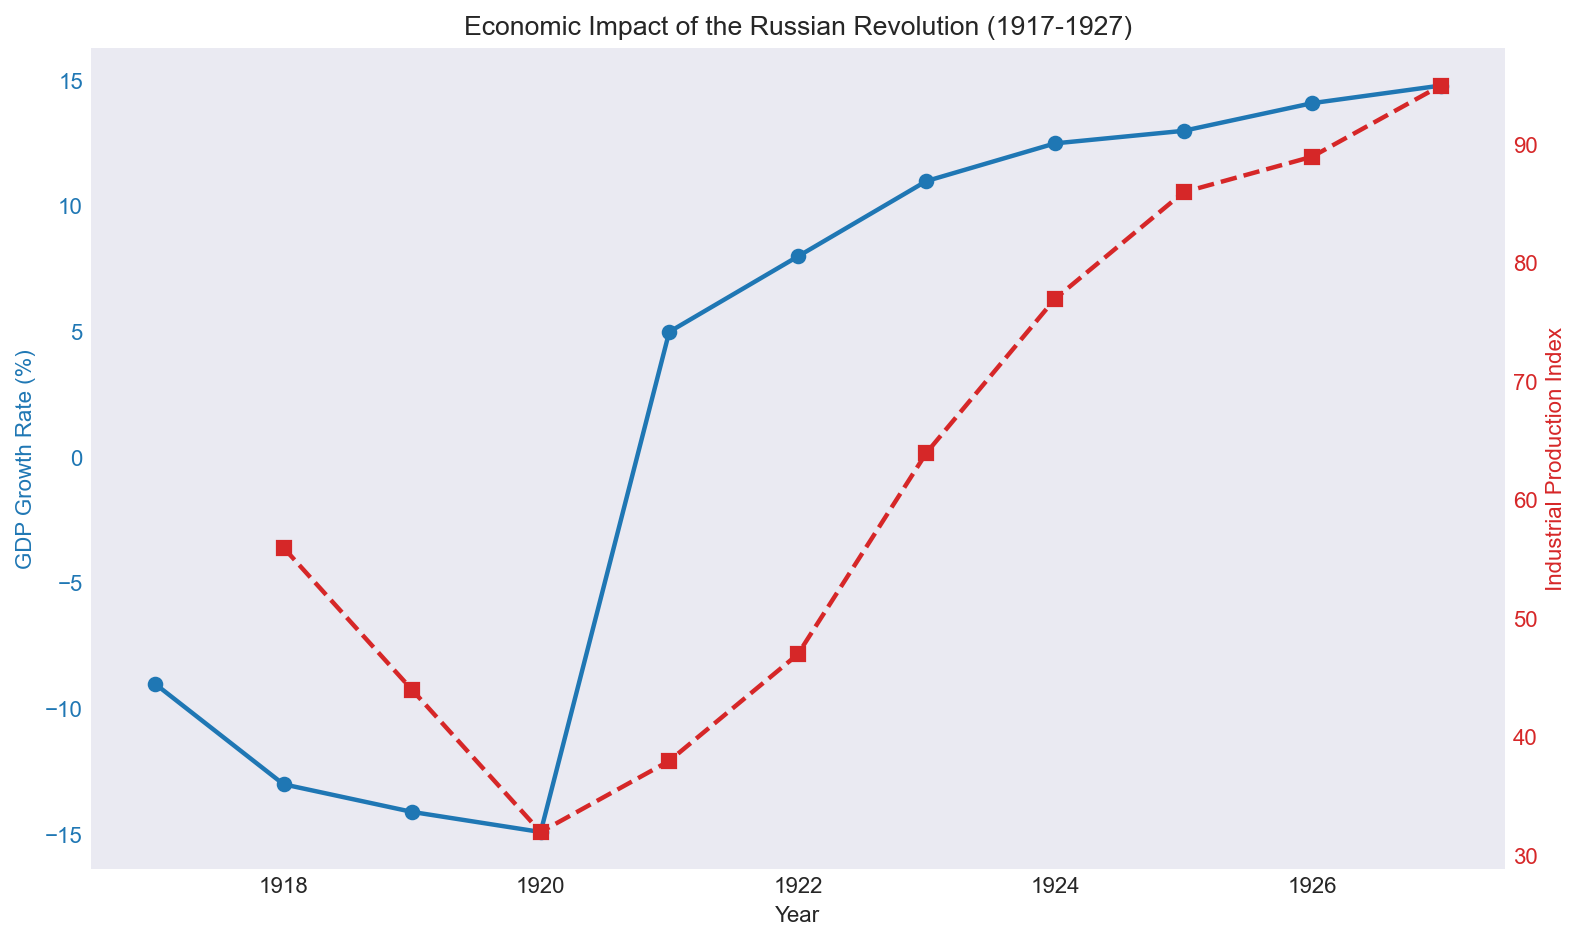What was the GDP growth rate in 1921? According to the chart, the GDP growth rate in 1921 was notable. By directly referencing the plotted data point for that year on the blue line, we observe that the GDP growth rate was 5.0%.
Answer: 5.0% Which year saw the lowest industrial production index? By examining the red dashed line, it is noticeable that the Industrial Production Index was at its lowest point in 1920, with a value of 32.
Answer: 1920 How did the industrial production change between 1922 and 1923? To determine the change, we need to observe the industrial production values for 1922 and 1923, which are 47 and 64 respectively. Subtracting these values (64 - 47) gives an increase of 17 points.
Answer: Increased by 17 points Was the industrial production index in 1926 higher than in 1924? To answer this, we compare the index values for 1926 and 1924. The index was 89 in 1926 and 77 in 1924. Since 89 is greater than 77, the industrial production index was higher in 1926.
Answer: Yes During what period did the GDP growth rate transition from negative to positive? Observing the GDP growth rate over the years, the transition from negative to positive growth occurs between 1920 (-14.9%) and 1921 (5.0%).
Answer: Between 1920 and 1921 What was the overall trend in industrial production from 1918 to 1927? The trend in industrial production can be observed along the red dashed line. There is an initial decline from 1918 to 1920, followed by a steady increase until 1927.
Answer: Declined and then increased Compare the GDP growth rate in 1919 and 1927, and indicate which year had a higher rate. The GDP growth rate in 1919 was -14.1%, while in 1927 it was 14.8%. Comparing these values, 14.8% is higher than -14.1%.
Answer: 1927 What is the difference in the GDP growth rate between 1918 and 1925? The GDP growth rates for 1918 and 1925 are -13.0% and 13.0%, respectively. The difference can be calculated as 13.0 - (-13.0) = 26.0%.
Answer: 26.0% In what year did the GDP growth rate experience its first positive increase after a series of declines? From the blue line on the chart, it's visible that after several years of decline, the first positive increase is observed in 1921.
Answer: 1921 